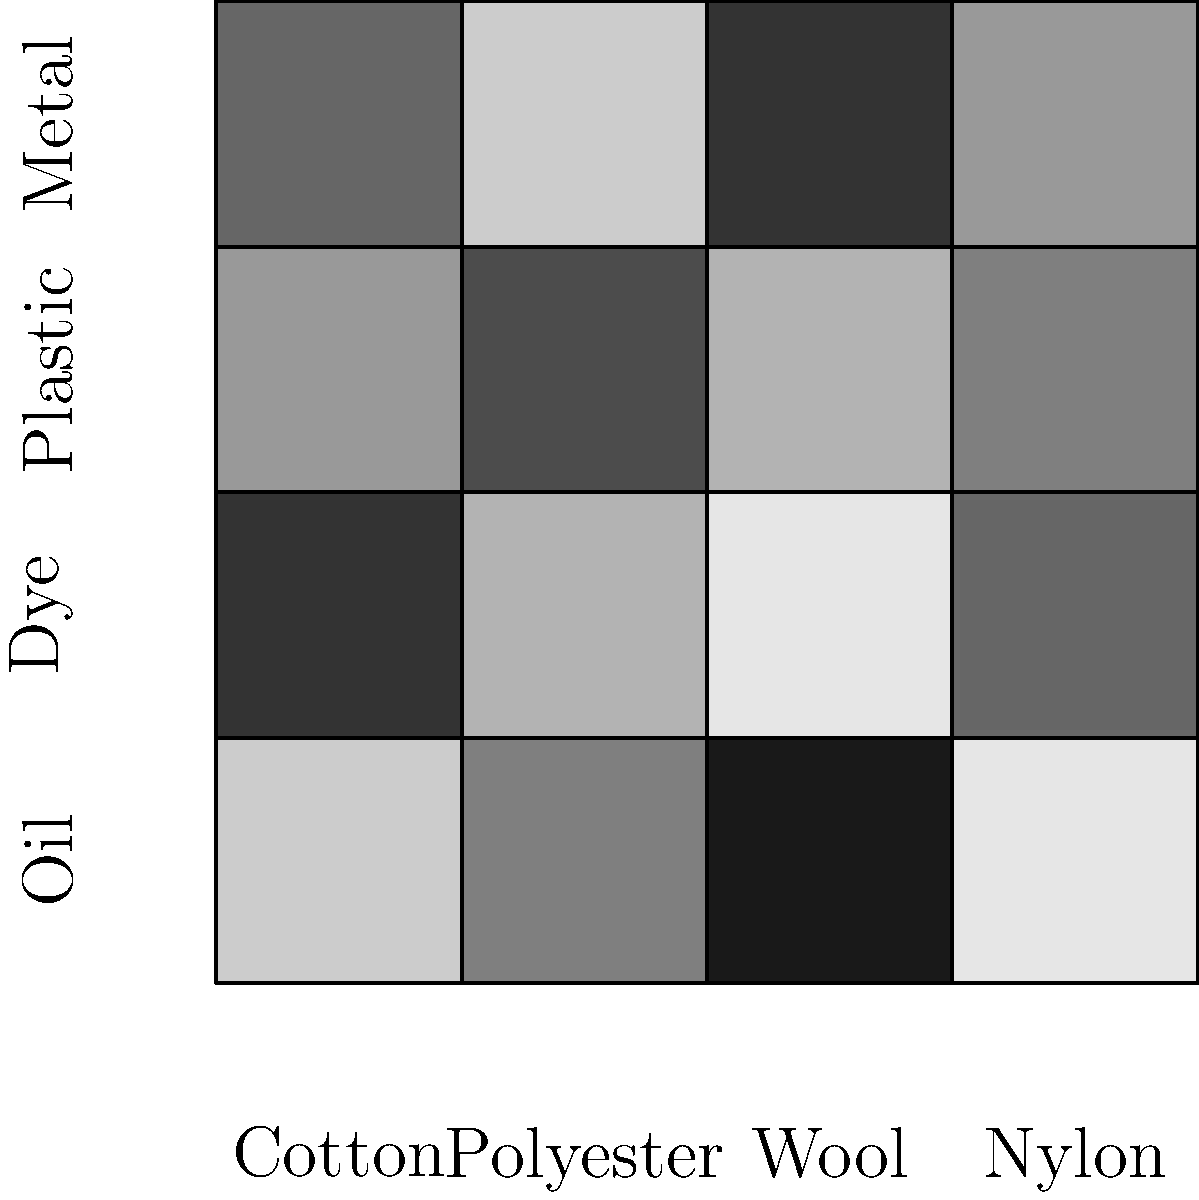Based on the heatmap of contaminant concentrations in different recycled fabrics, which fabric type shows the highest concentration of oil contamination, and what does this imply for the textile recycling process? To answer this question, we need to analyze the heatmap systematically:

1. The heatmap shows the concentration of four contaminants (Oil, Dye, Plastic, and Metal) across four fabric types (Cotton, Polyester, Wool, and Nylon).

2. The darkness of each cell represents the concentration of the contaminant, with darker cells indicating higher concentrations.

3. We need to focus on the "Oil" row of the heatmap, which is the top row.

4. Examining the Oil row:
   - Cotton (leftmost column): Light gray
   - Polyester (second column): Medium gray
   - Wool (third column): Very dark gray (almost black)
   - Nylon (rightmost column): Light gray

5. The darkest cell in the Oil row corresponds to Wool, indicating that Wool has the highest concentration of oil contamination.

6. This implies that in the textile recycling process:
   - Wool fabrics are more likely to retain oil-based contaminants.
   - Special attention should be given to cleaning and degreasing wool materials before recycling.
   - Additional processing steps or specialized cleaning agents may be required for wool to remove oil contaminants effectively.
   - The recycling process for wool might be more resource-intensive or costly due to the need for extra oil removal steps.
   - Quality control measures should be particularly stringent for recycled wool products to ensure oil contaminants have been sufficiently removed.
Answer: Wool; requires specialized oil removal in recycling process 